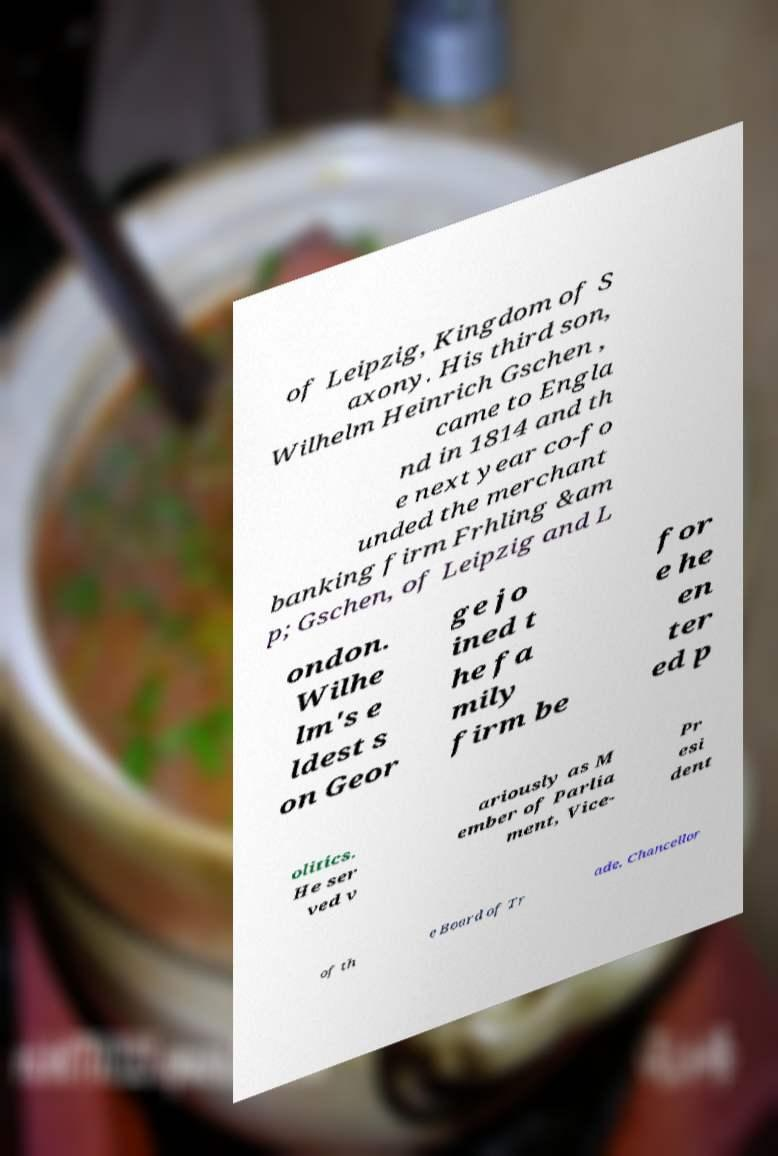Please identify and transcribe the text found in this image. of Leipzig, Kingdom of S axony. His third son, Wilhelm Heinrich Gschen , came to Engla nd in 1814 and th e next year co-fo unded the merchant banking firm Frhling &am p; Gschen, of Leipzig and L ondon. Wilhe lm's e ldest s on Geor ge jo ined t he fa mily firm be for e he en ter ed p olitics. He ser ved v ariously as M ember of Parlia ment, Vice- Pr esi dent of th e Board of Tr ade, Chancellor 